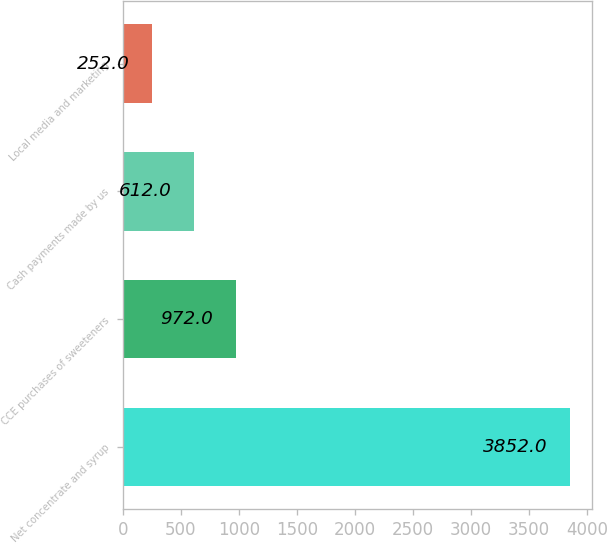<chart> <loc_0><loc_0><loc_500><loc_500><bar_chart><fcel>Net concentrate and syrup<fcel>CCE purchases of sweeteners<fcel>Cash payments made by us<fcel>Local media and marketing<nl><fcel>3852<fcel>972<fcel>612<fcel>252<nl></chart> 